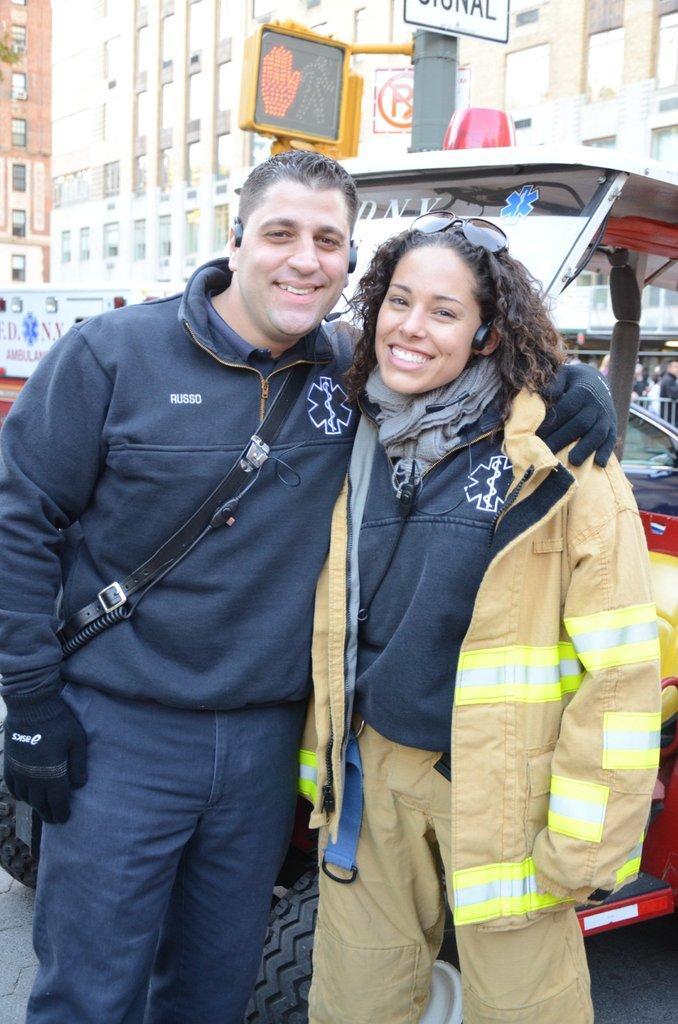Please provide a concise description of this image. In front of the image there are two people having a smile on their faces. Behind them there are vehicles. There are a few other people. In the background of the image there are buildings. There are directional boards. 